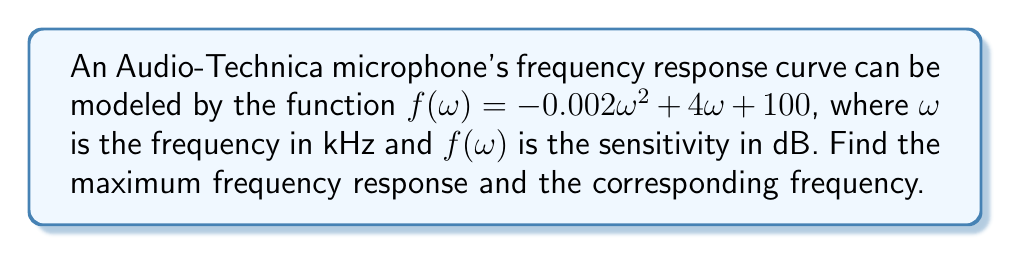Could you help me with this problem? To find the maximum frequency response, we need to find the maximum value of the function $f(\omega)$. This can be done using optimization techniques, specifically by finding where the derivative of the function equals zero.

Step 1: Calculate the derivative of $f(\omega)$.
$$f'(\omega) = -0.004\omega + 4$$

Step 2: Set the derivative equal to zero and solve for $\omega$.
$$-0.004\omega + 4 = 0$$
$$-0.004\omega = -4$$
$$\omega = \frac{-4}{-0.004} = 1000$$

Step 3: Verify that this critical point is a maximum by checking the second derivative.
$$f''(\omega) = -0.004$$
Since $f''(\omega)$ is negative, the critical point is a maximum.

Step 4: Calculate the maximum frequency response by plugging $\omega = 1000$ into the original function.
$$f(1000) = -0.002(1000)^2 + 4(1000) + 100$$
$$f(1000) = -2000 + 4000 + 100 = 2100$$

Therefore, the maximum frequency response occurs at 1000 kHz (or 1 MHz) with a sensitivity of 2100 dB.
Answer: Maximum at $\omega = 1000$ kHz, $f(1000) = 2100$ dB 